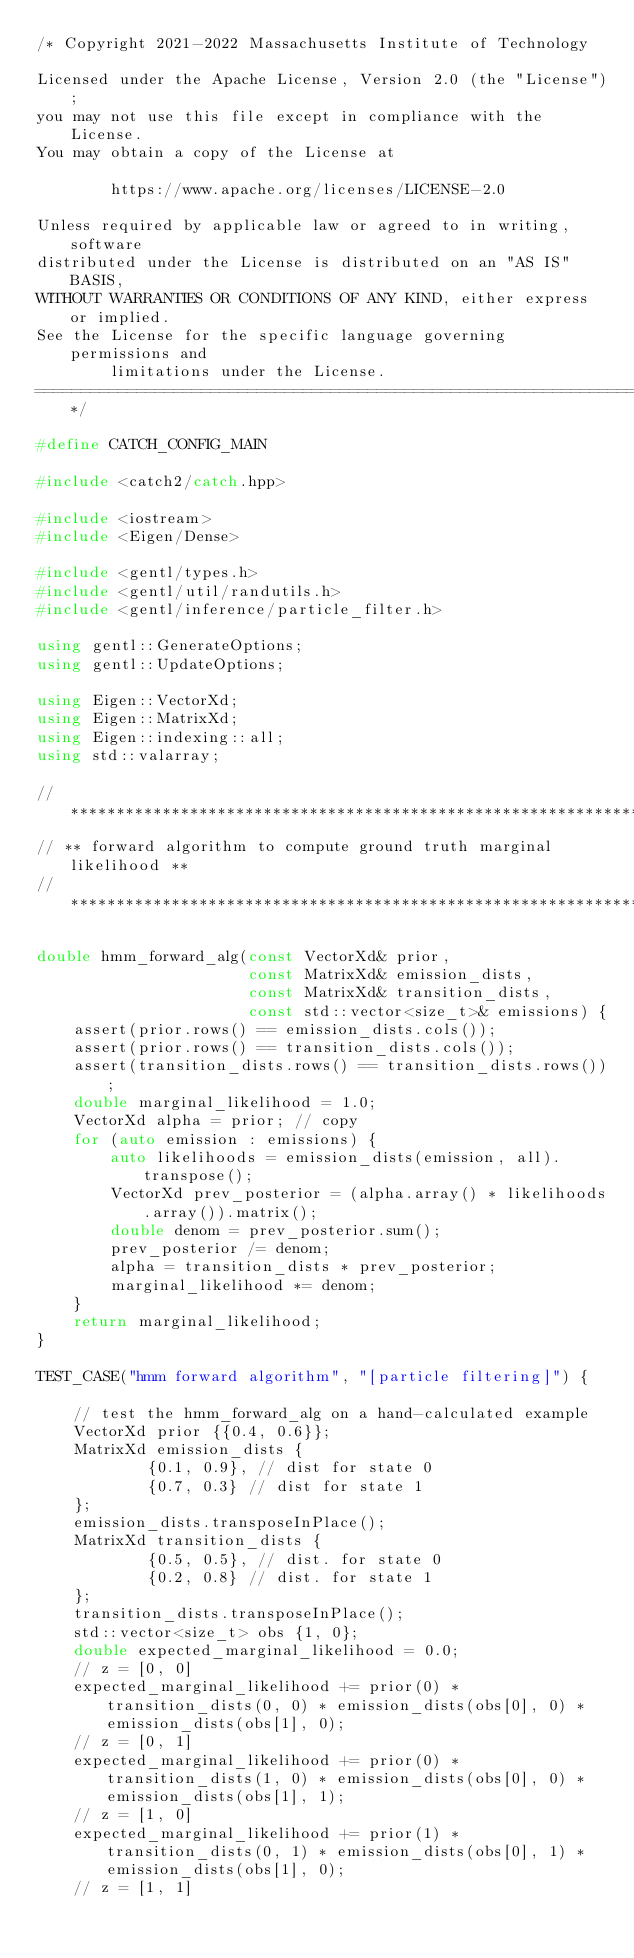<code> <loc_0><loc_0><loc_500><loc_500><_C++_>/* Copyright 2021-2022 Massachusetts Institute of Technology

Licensed under the Apache License, Version 2.0 (the "License");
you may not use this file except in compliance with the License.
You may obtain a copy of the License at

        https://www.apache.org/licenses/LICENSE-2.0

Unless required by applicable law or agreed to in writing, software
distributed under the License is distributed on an "AS IS" BASIS,
WITHOUT WARRANTIES OR CONDITIONS OF ANY KIND, either express or implied.
See the License for the specific language governing permissions and
        limitations under the License.
==============================================================================*/

#define CATCH_CONFIG_MAIN

#include <catch2/catch.hpp>

#include <iostream>
#include <Eigen/Dense>

#include <gentl/types.h>
#include <gentl/util/randutils.h>
#include <gentl/inference/particle_filter.h>

using gentl::GenerateOptions;
using gentl::UpdateOptions;

using Eigen::VectorXd;
using Eigen::MatrixXd;
using Eigen::indexing::all;
using std::valarray;

// *******************************************************************
// ** forward algorithm to compute ground truth marginal likelihood **
// *******************************************************************

double hmm_forward_alg(const VectorXd& prior,
                       const MatrixXd& emission_dists,
                       const MatrixXd& transition_dists,
                       const std::vector<size_t>& emissions) {
    assert(prior.rows() == emission_dists.cols());
    assert(prior.rows() == transition_dists.cols());
    assert(transition_dists.rows() == transition_dists.rows());
    double marginal_likelihood = 1.0;
    VectorXd alpha = prior; // copy
    for (auto emission : emissions) {
        auto likelihoods = emission_dists(emission, all).transpose();
        VectorXd prev_posterior = (alpha.array() * likelihoods.array()).matrix();
        double denom = prev_posterior.sum();
        prev_posterior /= denom;
        alpha = transition_dists * prev_posterior;
        marginal_likelihood *= denom;
    }
    return marginal_likelihood;
}

TEST_CASE("hmm forward algorithm", "[particle filtering]") {

    // test the hmm_forward_alg on a hand-calculated example
    VectorXd prior {{0.4, 0.6}};
    MatrixXd emission_dists {
            {0.1, 0.9}, // dist for state 0
            {0.7, 0.3} // dist for state 1
    };
    emission_dists.transposeInPlace();
    MatrixXd transition_dists {
            {0.5, 0.5}, // dist. for state 0
            {0.2, 0.8} // dist. for state 1
    };
    transition_dists.transposeInPlace();
    std::vector<size_t> obs {1, 0};
    double expected_marginal_likelihood = 0.0;
    // z = [0, 0]
    expected_marginal_likelihood += prior(0) * transition_dists(0, 0) * emission_dists(obs[0], 0) * emission_dists(obs[1], 0);
    // z = [0, 1]
    expected_marginal_likelihood += prior(0) * transition_dists(1, 0) * emission_dists(obs[0], 0) * emission_dists(obs[1], 1);
    // z = [1, 0]
    expected_marginal_likelihood += prior(1) * transition_dists(0, 1) * emission_dists(obs[0], 1) * emission_dists(obs[1], 0);
    // z = [1, 1]</code> 